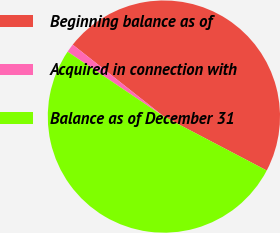Convert chart to OTSL. <chart><loc_0><loc_0><loc_500><loc_500><pie_chart><fcel>Beginning balance as of<fcel>Acquired in connection with<fcel>Balance as of December 31<nl><fcel>47.06%<fcel>1.2%<fcel>51.75%<nl></chart> 